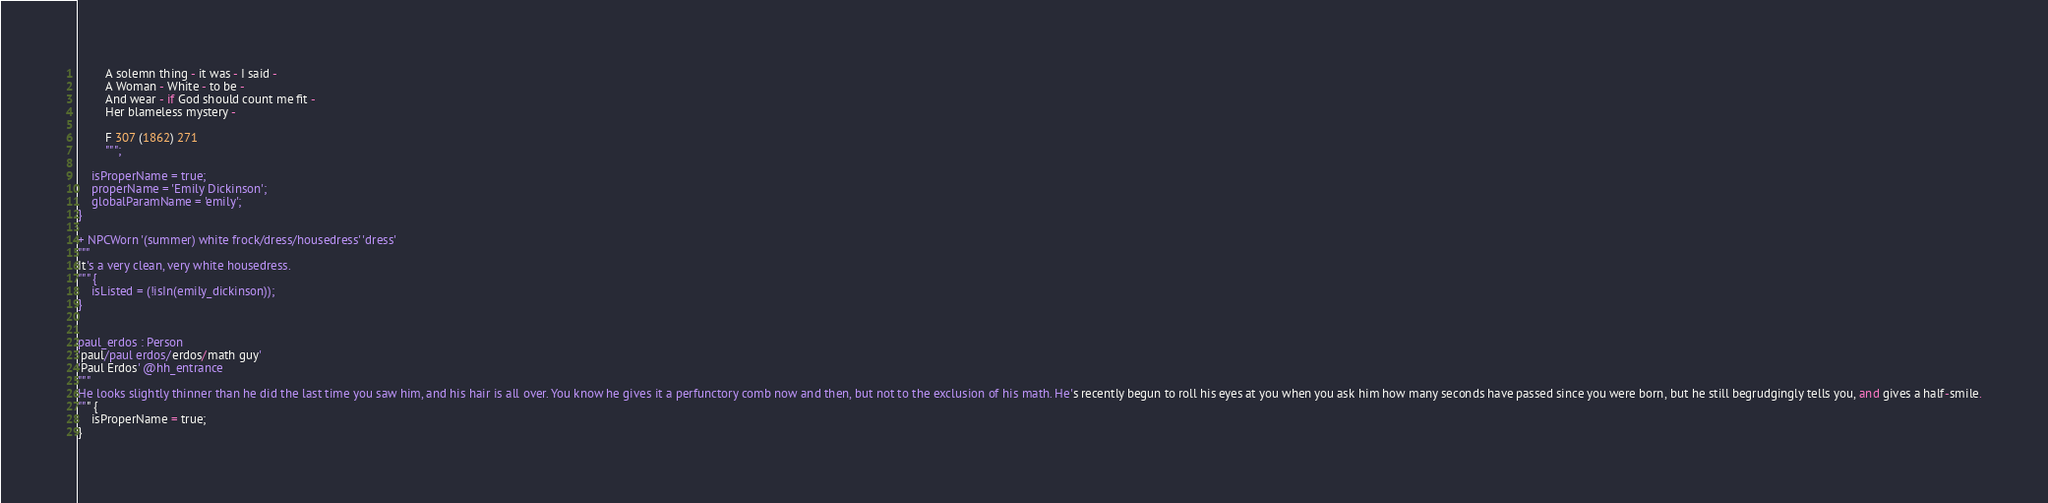Convert code to text. <code><loc_0><loc_0><loc_500><loc_500><_Perl_>        A solemn thing - it was - I said -
        A Woman - White - to be -
        And wear - if God should count me fit -
        Her blameless mystery -

        F 307 (1862) 271
        """;

    isProperName = true;
    properName = 'Emily Dickinson';
    globalParamName = 'emily';
}

+ NPCWorn '(summer) white frock/dress/housedress' 'dress'
"""
It's a very clean, very white housedress.
""" {
    isListed = (!isIn(emily_dickinson));
}


paul_erdos : Person
'paul/paul erdos/erdos/math guy'
'Paul Erdos' @hh_entrance
"""
He looks slightly thinner than he did the last time you saw him, and his hair is all over. You know he gives it a perfunctory comb now and then, but not to the exclusion of his math. He's recently begun to roll his eyes at you when you ask him how many seconds have passed since you were born, but he still begrudgingly tells you, and gives a half-smile.
""" {
    isProperName = true;
}

</code> 